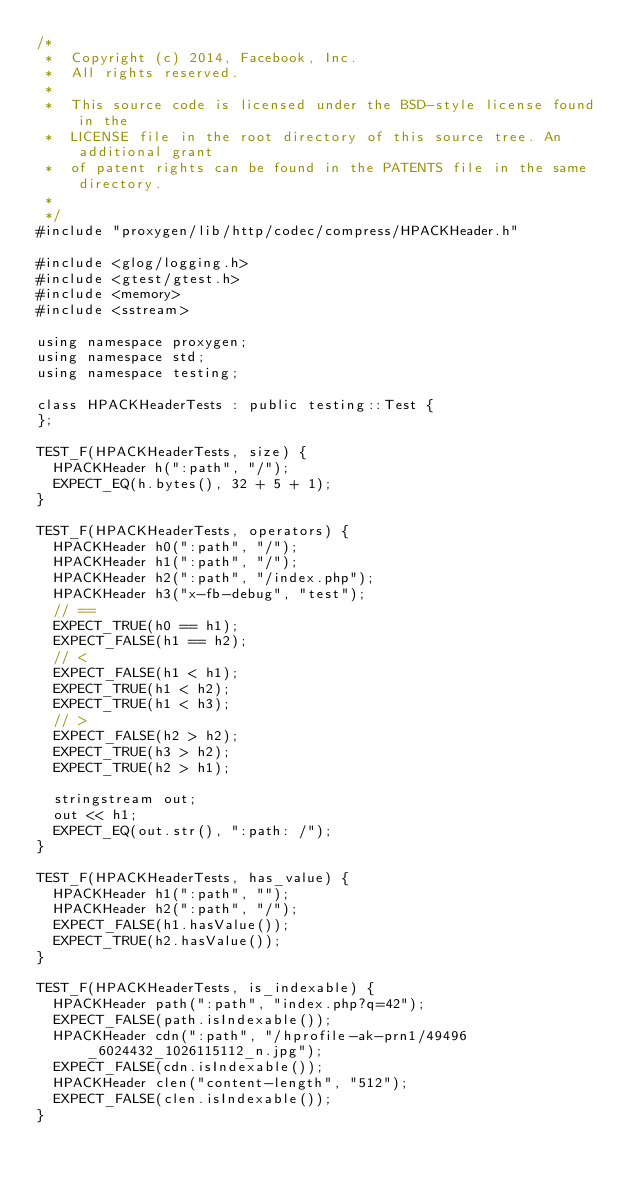Convert code to text. <code><loc_0><loc_0><loc_500><loc_500><_C++_>/*
 *  Copyright (c) 2014, Facebook, Inc.
 *  All rights reserved.
 *
 *  This source code is licensed under the BSD-style license found in the
 *  LICENSE file in the root directory of this source tree. An additional grant
 *  of patent rights can be found in the PATENTS file in the same directory.
 *
 */
#include "proxygen/lib/http/codec/compress/HPACKHeader.h"

#include <glog/logging.h>
#include <gtest/gtest.h>
#include <memory>
#include <sstream>

using namespace proxygen;
using namespace std;
using namespace testing;

class HPACKHeaderTests : public testing::Test {
};

TEST_F(HPACKHeaderTests, size) {
  HPACKHeader h(":path", "/");
  EXPECT_EQ(h.bytes(), 32 + 5 + 1);
}

TEST_F(HPACKHeaderTests, operators) {
  HPACKHeader h0(":path", "/");
  HPACKHeader h1(":path", "/");
  HPACKHeader h2(":path", "/index.php");
  HPACKHeader h3("x-fb-debug", "test");
  // ==
  EXPECT_TRUE(h0 == h1);
  EXPECT_FALSE(h1 == h2);
  // <
  EXPECT_FALSE(h1 < h1);
  EXPECT_TRUE(h1 < h2);
  EXPECT_TRUE(h1 < h3);
  // >
  EXPECT_FALSE(h2 > h2);
  EXPECT_TRUE(h3 > h2);
  EXPECT_TRUE(h2 > h1);

  stringstream out;
  out << h1;
  EXPECT_EQ(out.str(), ":path: /");
}

TEST_F(HPACKHeaderTests, has_value) {
  HPACKHeader h1(":path", "");
  HPACKHeader h2(":path", "/");
  EXPECT_FALSE(h1.hasValue());
  EXPECT_TRUE(h2.hasValue());
}

TEST_F(HPACKHeaderTests, is_indexable) {
  HPACKHeader path(":path", "index.php?q=42");
  EXPECT_FALSE(path.isIndexable());
  HPACKHeader cdn(":path", "/hprofile-ak-prn1/49496_6024432_1026115112_n.jpg");
  EXPECT_FALSE(cdn.isIndexable());
  HPACKHeader clen("content-length", "512");
  EXPECT_FALSE(clen.isIndexable());
}
</code> 